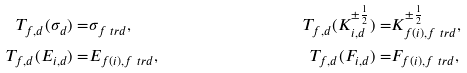<formula> <loc_0><loc_0><loc_500><loc_500>T _ { f , d } ( \sigma _ { d } ) = & \sigma _ { f \ t r d } , & T _ { f , d } ( K _ { i , d } ^ { \pm { \frac { 1 } { 2 } } } ) = & K _ { f ( i ) , f \ t r d } ^ { \pm { \frac { 1 } { 2 } } } , & \\ T _ { f , d } ( E _ { i , d } ) = & E _ { f ( i ) , f \ t r d } , & T _ { f , d } ( F _ { i , d } ) = & F _ { f ( i ) , f \ t r d } ,</formula> 